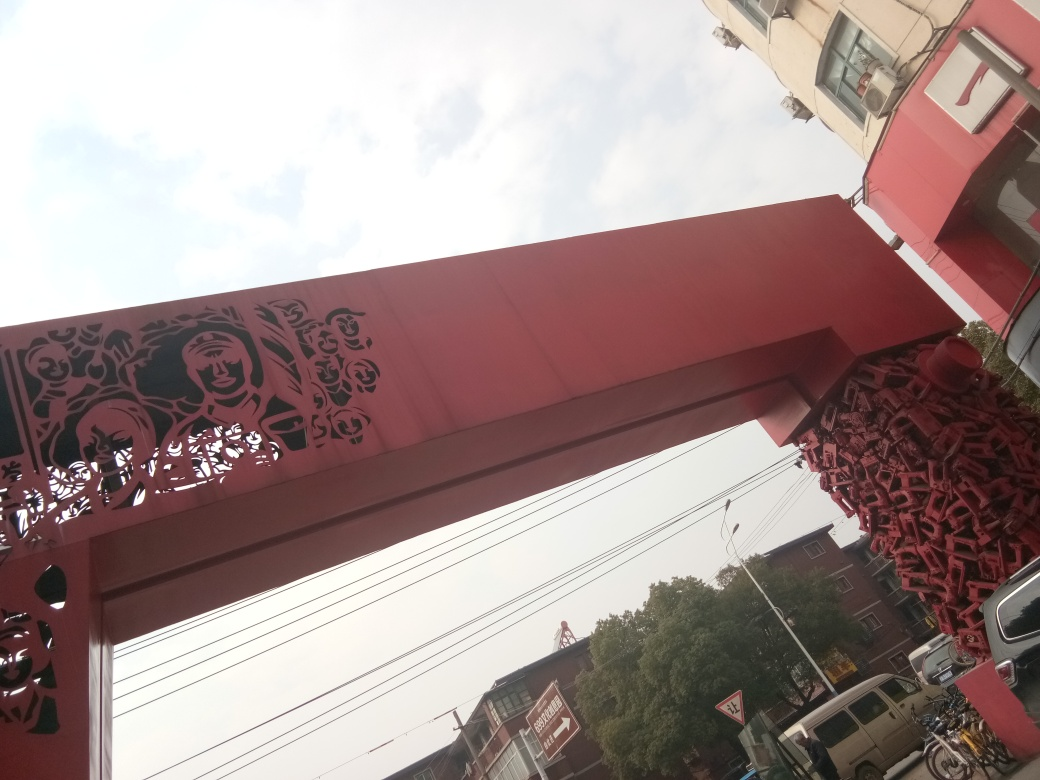Can you tell me what the focal point of this structure is? The focal point of the structure in the image appears to be its unique archway design with intricate cut-outs that depict figures. These cut-outs create an artistic and cultural centerpiece that naturally draws the viewer's attention. 